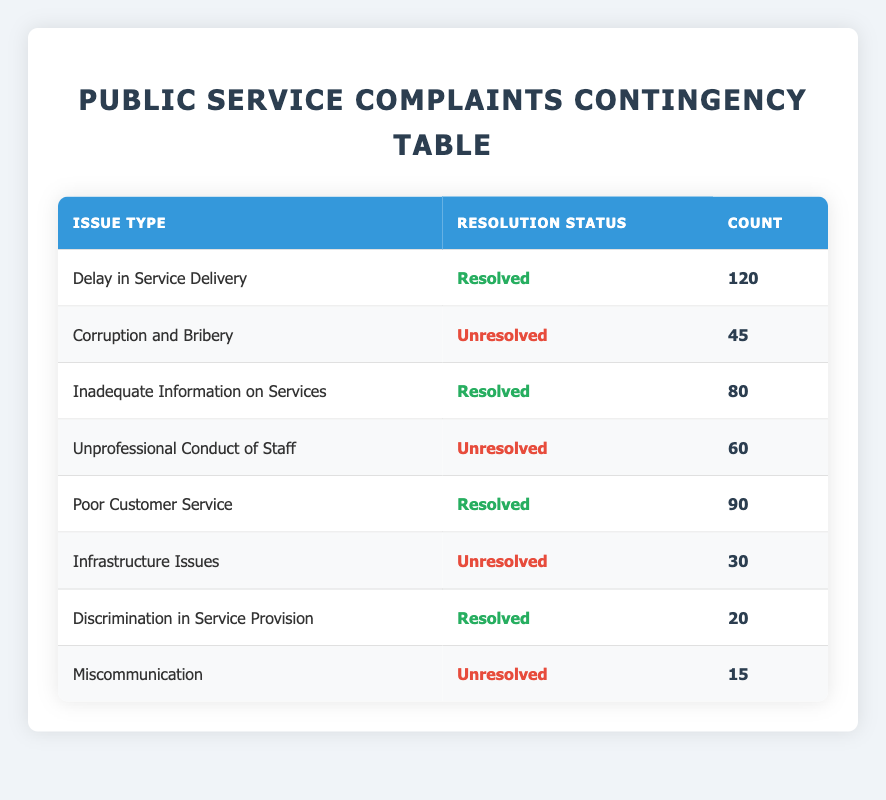What is the count of resolved complaints related to Delay in Service Delivery? According to the table, the complaint type "Delay in Service Delivery" has a resolution status of "Resolved" with a count of 120.
Answer: 120 How many complaints were classified as unresolved? By examining the table, the unresolved complaints are "Corruption and Bribery" with a count of 45, "Unprofessional Conduct of Staff" with a count of 60, "Infrastructure Issues" with a count of 30, and "Miscommunication" with a count of 15. Adding them up gives 45 + 60 + 30 + 15 = 150.
Answer: 150 Is there any complaint type that has more than 100 resolved cases? The complaints "Delay in Service Delivery" and "Poor Customer Service" have counts of 120 and 90 respectively. Therefore, only the "Delay in Service Delivery" has more than 100 resolved cases.
Answer: Yes What is the total count of all complaints that were resolved? From the table, the resolved complaints and their counts are: "Delay in Service Delivery" (120), "Inadequate Information on Services" (80), "Poor Customer Service" (90), and "Discrimination in Service Provision" (20). Thus, summing these gives 120 + 80 + 90 + 20 = 310.
Answer: 310 What percentage of complaints about Unprofessional Conduct of Staff were resolved? The table shows "Unprofessional Conduct of Staff" is unresolved (count of 60). There are no resolved cases for this type. Therefore, the percentage of resolved complaints is (0/60) * 100 = 0%.
Answer: 0% Which issue type has the highest unresolved count? The unresolved counts are: "Corruption and Bribery" (45), "Unprofessional Conduct of Staff" (60), "Infrastructure Issues" (30), and "Miscommunication" (15). The highest count is from "Unprofessional Conduct of Staff" at 60.
Answer: Unprofessional Conduct of Staff How many more complaints were resolved compared to unresolved? Total resolved complaints: "Delay in Service Delivery" (120) + "Inadequate Information on Services" (80) + "Poor Customer Service" (90) + "Discrimination in Service Provision" (20) = 310. Total unresolved complaints: 150. The difference is 310 - 150 = 160.
Answer: 160 What is the total number of complaints reported in the table? By aggregating all counts, we find the total complaints: 120 (Resolved) + 45 (Unresolved) + 80 (Resolved) + 60 (Unresolved) + 90 (Resolved) + 30 (Unresolved) + 20 (Resolved) + 15 (Unresolved) = 450.
Answer: 450 